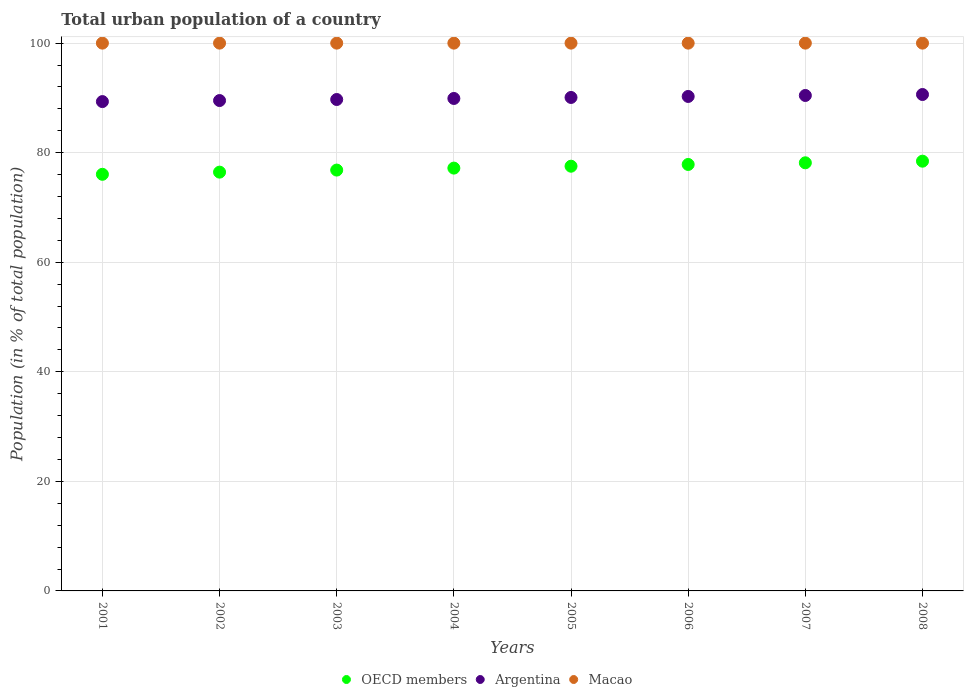What is the urban population in Argentina in 2003?
Your response must be concise. 89.71. Across all years, what is the maximum urban population in Argentina?
Your answer should be compact. 90.62. Across all years, what is the minimum urban population in Argentina?
Provide a short and direct response. 89.33. What is the total urban population in Macao in the graph?
Keep it short and to the point. 800. What is the difference between the urban population in Argentina in 2005 and that in 2007?
Give a very brief answer. -0.36. What is the difference between the urban population in OECD members in 2006 and the urban population in Argentina in 2004?
Provide a succinct answer. -12.05. What is the average urban population in OECD members per year?
Your answer should be very brief. 77.31. In the year 2005, what is the difference between the urban population in Argentina and urban population in Macao?
Your answer should be very brief. -9.92. What is the ratio of the urban population in OECD members in 2003 to that in 2008?
Keep it short and to the point. 0.98. What is the difference between the highest and the second highest urban population in Argentina?
Offer a terse response. 0.18. What is the difference between the highest and the lowest urban population in Macao?
Offer a terse response. 0. Is it the case that in every year, the sum of the urban population in Macao and urban population in OECD members  is greater than the urban population in Argentina?
Keep it short and to the point. Yes. Does the urban population in Macao monotonically increase over the years?
Ensure brevity in your answer.  No. What is the difference between two consecutive major ticks on the Y-axis?
Give a very brief answer. 20. Does the graph contain any zero values?
Your answer should be compact. No. Where does the legend appear in the graph?
Your answer should be compact. Bottom center. How many legend labels are there?
Keep it short and to the point. 3. How are the legend labels stacked?
Offer a very short reply. Horizontal. What is the title of the graph?
Ensure brevity in your answer.  Total urban population of a country. What is the label or title of the Y-axis?
Your answer should be compact. Population (in % of total population). What is the Population (in % of total population) of OECD members in 2001?
Provide a short and direct response. 76.05. What is the Population (in % of total population) in Argentina in 2001?
Your response must be concise. 89.33. What is the Population (in % of total population) of OECD members in 2002?
Offer a terse response. 76.45. What is the Population (in % of total population) of Argentina in 2002?
Offer a very short reply. 89.52. What is the Population (in % of total population) of Macao in 2002?
Offer a very short reply. 100. What is the Population (in % of total population) of OECD members in 2003?
Provide a short and direct response. 76.83. What is the Population (in % of total population) of Argentina in 2003?
Offer a very short reply. 89.71. What is the Population (in % of total population) of OECD members in 2004?
Offer a very short reply. 77.19. What is the Population (in % of total population) in Argentina in 2004?
Your response must be concise. 89.9. What is the Population (in % of total population) in OECD members in 2005?
Your answer should be compact. 77.53. What is the Population (in % of total population) of Argentina in 2005?
Your answer should be compact. 90.08. What is the Population (in % of total population) in Macao in 2005?
Your answer should be compact. 100. What is the Population (in % of total population) of OECD members in 2006?
Your answer should be very brief. 77.85. What is the Population (in % of total population) of Argentina in 2006?
Provide a short and direct response. 90.27. What is the Population (in % of total population) in Macao in 2006?
Offer a terse response. 100. What is the Population (in % of total population) in OECD members in 2007?
Keep it short and to the point. 78.15. What is the Population (in % of total population) in Argentina in 2007?
Your answer should be compact. 90.44. What is the Population (in % of total population) of Macao in 2007?
Your answer should be very brief. 100. What is the Population (in % of total population) of OECD members in 2008?
Your response must be concise. 78.45. What is the Population (in % of total population) in Argentina in 2008?
Give a very brief answer. 90.62. Across all years, what is the maximum Population (in % of total population) in OECD members?
Keep it short and to the point. 78.45. Across all years, what is the maximum Population (in % of total population) in Argentina?
Your answer should be very brief. 90.62. Across all years, what is the maximum Population (in % of total population) in Macao?
Offer a very short reply. 100. Across all years, what is the minimum Population (in % of total population) of OECD members?
Give a very brief answer. 76.05. Across all years, what is the minimum Population (in % of total population) of Argentina?
Your answer should be very brief. 89.33. Across all years, what is the minimum Population (in % of total population) in Macao?
Keep it short and to the point. 100. What is the total Population (in % of total population) in OECD members in the graph?
Provide a short and direct response. 618.51. What is the total Population (in % of total population) in Argentina in the graph?
Your answer should be compact. 719.87. What is the total Population (in % of total population) in Macao in the graph?
Provide a succinct answer. 800. What is the difference between the Population (in % of total population) of OECD members in 2001 and that in 2002?
Offer a very short reply. -0.4. What is the difference between the Population (in % of total population) in Argentina in 2001 and that in 2002?
Keep it short and to the point. -0.19. What is the difference between the Population (in % of total population) in OECD members in 2001 and that in 2003?
Keep it short and to the point. -0.77. What is the difference between the Population (in % of total population) in Argentina in 2001 and that in 2003?
Provide a succinct answer. -0.38. What is the difference between the Population (in % of total population) in OECD members in 2001 and that in 2004?
Offer a very short reply. -1.13. What is the difference between the Population (in % of total population) of Argentina in 2001 and that in 2004?
Offer a terse response. -0.57. What is the difference between the Population (in % of total population) of Macao in 2001 and that in 2004?
Offer a very short reply. 0. What is the difference between the Population (in % of total population) of OECD members in 2001 and that in 2005?
Provide a short and direct response. -1.48. What is the difference between the Population (in % of total population) of Argentina in 2001 and that in 2005?
Keep it short and to the point. -0.76. What is the difference between the Population (in % of total population) of Macao in 2001 and that in 2005?
Provide a short and direct response. 0. What is the difference between the Population (in % of total population) in OECD members in 2001 and that in 2006?
Keep it short and to the point. -1.8. What is the difference between the Population (in % of total population) of Argentina in 2001 and that in 2006?
Ensure brevity in your answer.  -0.94. What is the difference between the Population (in % of total population) in OECD members in 2001 and that in 2007?
Provide a short and direct response. -2.1. What is the difference between the Population (in % of total population) of Argentina in 2001 and that in 2007?
Offer a very short reply. -1.12. What is the difference between the Population (in % of total population) of OECD members in 2001 and that in 2008?
Your answer should be very brief. -2.4. What is the difference between the Population (in % of total population) of Argentina in 2001 and that in 2008?
Offer a terse response. -1.29. What is the difference between the Population (in % of total population) in OECD members in 2002 and that in 2003?
Provide a succinct answer. -0.38. What is the difference between the Population (in % of total population) of Argentina in 2002 and that in 2003?
Give a very brief answer. -0.19. What is the difference between the Population (in % of total population) in Macao in 2002 and that in 2003?
Your answer should be compact. 0. What is the difference between the Population (in % of total population) of OECD members in 2002 and that in 2004?
Your answer should be very brief. -0.74. What is the difference between the Population (in % of total population) of Argentina in 2002 and that in 2004?
Ensure brevity in your answer.  -0.38. What is the difference between the Population (in % of total population) of Macao in 2002 and that in 2004?
Your answer should be very brief. 0. What is the difference between the Population (in % of total population) of OECD members in 2002 and that in 2005?
Ensure brevity in your answer.  -1.08. What is the difference between the Population (in % of total population) in Argentina in 2002 and that in 2005?
Provide a short and direct response. -0.56. What is the difference between the Population (in % of total population) in OECD members in 2002 and that in 2006?
Offer a terse response. -1.4. What is the difference between the Population (in % of total population) in Argentina in 2002 and that in 2006?
Give a very brief answer. -0.75. What is the difference between the Population (in % of total population) of OECD members in 2002 and that in 2007?
Make the answer very short. -1.7. What is the difference between the Population (in % of total population) of Argentina in 2002 and that in 2007?
Your answer should be very brief. -0.93. What is the difference between the Population (in % of total population) in Macao in 2002 and that in 2007?
Your answer should be very brief. 0. What is the difference between the Population (in % of total population) in OECD members in 2002 and that in 2008?
Offer a terse response. -2. What is the difference between the Population (in % of total population) of Argentina in 2002 and that in 2008?
Offer a terse response. -1.1. What is the difference between the Population (in % of total population) of Macao in 2002 and that in 2008?
Offer a terse response. 0. What is the difference between the Population (in % of total population) in OECD members in 2003 and that in 2004?
Your answer should be compact. -0.36. What is the difference between the Population (in % of total population) of Argentina in 2003 and that in 2004?
Provide a succinct answer. -0.19. What is the difference between the Population (in % of total population) of Macao in 2003 and that in 2004?
Provide a short and direct response. 0. What is the difference between the Population (in % of total population) of OECD members in 2003 and that in 2005?
Provide a short and direct response. -0.71. What is the difference between the Population (in % of total population) of Argentina in 2003 and that in 2005?
Provide a short and direct response. -0.37. What is the difference between the Population (in % of total population) of OECD members in 2003 and that in 2006?
Keep it short and to the point. -1.02. What is the difference between the Population (in % of total population) of Argentina in 2003 and that in 2006?
Keep it short and to the point. -0.56. What is the difference between the Population (in % of total population) of OECD members in 2003 and that in 2007?
Keep it short and to the point. -1.33. What is the difference between the Population (in % of total population) in Argentina in 2003 and that in 2007?
Make the answer very short. -0.73. What is the difference between the Population (in % of total population) in OECD members in 2003 and that in 2008?
Your response must be concise. -1.62. What is the difference between the Population (in % of total population) of Argentina in 2003 and that in 2008?
Keep it short and to the point. -0.91. What is the difference between the Population (in % of total population) in OECD members in 2004 and that in 2005?
Make the answer very short. -0.35. What is the difference between the Population (in % of total population) in Argentina in 2004 and that in 2005?
Give a very brief answer. -0.18. What is the difference between the Population (in % of total population) in Macao in 2004 and that in 2005?
Give a very brief answer. 0. What is the difference between the Population (in % of total population) in OECD members in 2004 and that in 2006?
Provide a short and direct response. -0.66. What is the difference between the Population (in % of total population) of Argentina in 2004 and that in 2006?
Offer a terse response. -0.37. What is the difference between the Population (in % of total population) of OECD members in 2004 and that in 2007?
Your answer should be compact. -0.97. What is the difference between the Population (in % of total population) in Argentina in 2004 and that in 2007?
Provide a succinct answer. -0.55. What is the difference between the Population (in % of total population) in Macao in 2004 and that in 2007?
Provide a short and direct response. 0. What is the difference between the Population (in % of total population) of OECD members in 2004 and that in 2008?
Ensure brevity in your answer.  -1.26. What is the difference between the Population (in % of total population) of Argentina in 2004 and that in 2008?
Make the answer very short. -0.72. What is the difference between the Population (in % of total population) in OECD members in 2005 and that in 2006?
Provide a short and direct response. -0.32. What is the difference between the Population (in % of total population) of Argentina in 2005 and that in 2006?
Provide a short and direct response. -0.18. What is the difference between the Population (in % of total population) in OECD members in 2005 and that in 2007?
Give a very brief answer. -0.62. What is the difference between the Population (in % of total population) of Argentina in 2005 and that in 2007?
Give a very brief answer. -0.36. What is the difference between the Population (in % of total population) in OECD members in 2005 and that in 2008?
Give a very brief answer. -0.92. What is the difference between the Population (in % of total population) of Argentina in 2005 and that in 2008?
Offer a very short reply. -0.54. What is the difference between the Population (in % of total population) of Macao in 2005 and that in 2008?
Give a very brief answer. 0. What is the difference between the Population (in % of total population) in OECD members in 2006 and that in 2007?
Make the answer very short. -0.3. What is the difference between the Population (in % of total population) of Argentina in 2006 and that in 2007?
Provide a succinct answer. -0.18. What is the difference between the Population (in % of total population) in Macao in 2006 and that in 2007?
Your answer should be very brief. 0. What is the difference between the Population (in % of total population) of OECD members in 2006 and that in 2008?
Provide a short and direct response. -0.6. What is the difference between the Population (in % of total population) of Argentina in 2006 and that in 2008?
Ensure brevity in your answer.  -0.36. What is the difference between the Population (in % of total population) in Macao in 2006 and that in 2008?
Keep it short and to the point. 0. What is the difference between the Population (in % of total population) in OECD members in 2007 and that in 2008?
Keep it short and to the point. -0.3. What is the difference between the Population (in % of total population) of Argentina in 2007 and that in 2008?
Keep it short and to the point. -0.18. What is the difference between the Population (in % of total population) of OECD members in 2001 and the Population (in % of total population) of Argentina in 2002?
Offer a very short reply. -13.46. What is the difference between the Population (in % of total population) of OECD members in 2001 and the Population (in % of total population) of Macao in 2002?
Your response must be concise. -23.95. What is the difference between the Population (in % of total population) of Argentina in 2001 and the Population (in % of total population) of Macao in 2002?
Keep it short and to the point. -10.67. What is the difference between the Population (in % of total population) of OECD members in 2001 and the Population (in % of total population) of Argentina in 2003?
Offer a very short reply. -13.66. What is the difference between the Population (in % of total population) in OECD members in 2001 and the Population (in % of total population) in Macao in 2003?
Your response must be concise. -23.95. What is the difference between the Population (in % of total population) of Argentina in 2001 and the Population (in % of total population) of Macao in 2003?
Your answer should be compact. -10.67. What is the difference between the Population (in % of total population) in OECD members in 2001 and the Population (in % of total population) in Argentina in 2004?
Give a very brief answer. -13.84. What is the difference between the Population (in % of total population) in OECD members in 2001 and the Population (in % of total population) in Macao in 2004?
Ensure brevity in your answer.  -23.95. What is the difference between the Population (in % of total population) in Argentina in 2001 and the Population (in % of total population) in Macao in 2004?
Keep it short and to the point. -10.67. What is the difference between the Population (in % of total population) of OECD members in 2001 and the Population (in % of total population) of Argentina in 2005?
Offer a very short reply. -14.03. What is the difference between the Population (in % of total population) in OECD members in 2001 and the Population (in % of total population) in Macao in 2005?
Make the answer very short. -23.95. What is the difference between the Population (in % of total population) of Argentina in 2001 and the Population (in % of total population) of Macao in 2005?
Make the answer very short. -10.67. What is the difference between the Population (in % of total population) of OECD members in 2001 and the Population (in % of total population) of Argentina in 2006?
Provide a succinct answer. -14.21. What is the difference between the Population (in % of total population) of OECD members in 2001 and the Population (in % of total population) of Macao in 2006?
Make the answer very short. -23.95. What is the difference between the Population (in % of total population) of Argentina in 2001 and the Population (in % of total population) of Macao in 2006?
Offer a terse response. -10.67. What is the difference between the Population (in % of total population) of OECD members in 2001 and the Population (in % of total population) of Argentina in 2007?
Offer a terse response. -14.39. What is the difference between the Population (in % of total population) in OECD members in 2001 and the Population (in % of total population) in Macao in 2007?
Offer a terse response. -23.95. What is the difference between the Population (in % of total population) in Argentina in 2001 and the Population (in % of total population) in Macao in 2007?
Offer a terse response. -10.67. What is the difference between the Population (in % of total population) in OECD members in 2001 and the Population (in % of total population) in Argentina in 2008?
Keep it short and to the point. -14.57. What is the difference between the Population (in % of total population) of OECD members in 2001 and the Population (in % of total population) of Macao in 2008?
Your answer should be very brief. -23.95. What is the difference between the Population (in % of total population) of Argentina in 2001 and the Population (in % of total population) of Macao in 2008?
Ensure brevity in your answer.  -10.67. What is the difference between the Population (in % of total population) of OECD members in 2002 and the Population (in % of total population) of Argentina in 2003?
Make the answer very short. -13.26. What is the difference between the Population (in % of total population) in OECD members in 2002 and the Population (in % of total population) in Macao in 2003?
Provide a succinct answer. -23.55. What is the difference between the Population (in % of total population) in Argentina in 2002 and the Population (in % of total population) in Macao in 2003?
Your answer should be compact. -10.48. What is the difference between the Population (in % of total population) of OECD members in 2002 and the Population (in % of total population) of Argentina in 2004?
Offer a terse response. -13.45. What is the difference between the Population (in % of total population) in OECD members in 2002 and the Population (in % of total population) in Macao in 2004?
Give a very brief answer. -23.55. What is the difference between the Population (in % of total population) in Argentina in 2002 and the Population (in % of total population) in Macao in 2004?
Make the answer very short. -10.48. What is the difference between the Population (in % of total population) in OECD members in 2002 and the Population (in % of total population) in Argentina in 2005?
Your response must be concise. -13.63. What is the difference between the Population (in % of total population) of OECD members in 2002 and the Population (in % of total population) of Macao in 2005?
Offer a terse response. -23.55. What is the difference between the Population (in % of total population) of Argentina in 2002 and the Population (in % of total population) of Macao in 2005?
Offer a very short reply. -10.48. What is the difference between the Population (in % of total population) in OECD members in 2002 and the Population (in % of total population) in Argentina in 2006?
Provide a succinct answer. -13.82. What is the difference between the Population (in % of total population) in OECD members in 2002 and the Population (in % of total population) in Macao in 2006?
Provide a short and direct response. -23.55. What is the difference between the Population (in % of total population) in Argentina in 2002 and the Population (in % of total population) in Macao in 2006?
Keep it short and to the point. -10.48. What is the difference between the Population (in % of total population) in OECD members in 2002 and the Population (in % of total population) in Argentina in 2007?
Your response must be concise. -14. What is the difference between the Population (in % of total population) in OECD members in 2002 and the Population (in % of total population) in Macao in 2007?
Ensure brevity in your answer.  -23.55. What is the difference between the Population (in % of total population) in Argentina in 2002 and the Population (in % of total population) in Macao in 2007?
Provide a succinct answer. -10.48. What is the difference between the Population (in % of total population) in OECD members in 2002 and the Population (in % of total population) in Argentina in 2008?
Offer a very short reply. -14.17. What is the difference between the Population (in % of total population) in OECD members in 2002 and the Population (in % of total population) in Macao in 2008?
Offer a terse response. -23.55. What is the difference between the Population (in % of total population) of Argentina in 2002 and the Population (in % of total population) of Macao in 2008?
Your answer should be very brief. -10.48. What is the difference between the Population (in % of total population) of OECD members in 2003 and the Population (in % of total population) of Argentina in 2004?
Ensure brevity in your answer.  -13.07. What is the difference between the Population (in % of total population) of OECD members in 2003 and the Population (in % of total population) of Macao in 2004?
Give a very brief answer. -23.17. What is the difference between the Population (in % of total population) in Argentina in 2003 and the Population (in % of total population) in Macao in 2004?
Your answer should be compact. -10.29. What is the difference between the Population (in % of total population) of OECD members in 2003 and the Population (in % of total population) of Argentina in 2005?
Provide a succinct answer. -13.26. What is the difference between the Population (in % of total population) in OECD members in 2003 and the Population (in % of total population) in Macao in 2005?
Provide a succinct answer. -23.17. What is the difference between the Population (in % of total population) in Argentina in 2003 and the Population (in % of total population) in Macao in 2005?
Make the answer very short. -10.29. What is the difference between the Population (in % of total population) of OECD members in 2003 and the Population (in % of total population) of Argentina in 2006?
Offer a terse response. -13.44. What is the difference between the Population (in % of total population) of OECD members in 2003 and the Population (in % of total population) of Macao in 2006?
Offer a terse response. -23.17. What is the difference between the Population (in % of total population) in Argentina in 2003 and the Population (in % of total population) in Macao in 2006?
Make the answer very short. -10.29. What is the difference between the Population (in % of total population) in OECD members in 2003 and the Population (in % of total population) in Argentina in 2007?
Your response must be concise. -13.62. What is the difference between the Population (in % of total population) of OECD members in 2003 and the Population (in % of total population) of Macao in 2007?
Give a very brief answer. -23.17. What is the difference between the Population (in % of total population) of Argentina in 2003 and the Population (in % of total population) of Macao in 2007?
Your response must be concise. -10.29. What is the difference between the Population (in % of total population) of OECD members in 2003 and the Population (in % of total population) of Argentina in 2008?
Make the answer very short. -13.8. What is the difference between the Population (in % of total population) in OECD members in 2003 and the Population (in % of total population) in Macao in 2008?
Your response must be concise. -23.17. What is the difference between the Population (in % of total population) in Argentina in 2003 and the Population (in % of total population) in Macao in 2008?
Keep it short and to the point. -10.29. What is the difference between the Population (in % of total population) of OECD members in 2004 and the Population (in % of total population) of Argentina in 2005?
Ensure brevity in your answer.  -12.9. What is the difference between the Population (in % of total population) in OECD members in 2004 and the Population (in % of total population) in Macao in 2005?
Ensure brevity in your answer.  -22.81. What is the difference between the Population (in % of total population) of Argentina in 2004 and the Population (in % of total population) of Macao in 2005?
Your answer should be very brief. -10.1. What is the difference between the Population (in % of total population) in OECD members in 2004 and the Population (in % of total population) in Argentina in 2006?
Provide a succinct answer. -13.08. What is the difference between the Population (in % of total population) of OECD members in 2004 and the Population (in % of total population) of Macao in 2006?
Give a very brief answer. -22.81. What is the difference between the Population (in % of total population) in Argentina in 2004 and the Population (in % of total population) in Macao in 2006?
Provide a succinct answer. -10.1. What is the difference between the Population (in % of total population) of OECD members in 2004 and the Population (in % of total population) of Argentina in 2007?
Your answer should be compact. -13.26. What is the difference between the Population (in % of total population) of OECD members in 2004 and the Population (in % of total population) of Macao in 2007?
Your response must be concise. -22.81. What is the difference between the Population (in % of total population) of Argentina in 2004 and the Population (in % of total population) of Macao in 2007?
Give a very brief answer. -10.1. What is the difference between the Population (in % of total population) of OECD members in 2004 and the Population (in % of total population) of Argentina in 2008?
Offer a very short reply. -13.44. What is the difference between the Population (in % of total population) in OECD members in 2004 and the Population (in % of total population) in Macao in 2008?
Make the answer very short. -22.81. What is the difference between the Population (in % of total population) in Argentina in 2004 and the Population (in % of total population) in Macao in 2008?
Your answer should be compact. -10.1. What is the difference between the Population (in % of total population) in OECD members in 2005 and the Population (in % of total population) in Argentina in 2006?
Make the answer very short. -12.73. What is the difference between the Population (in % of total population) of OECD members in 2005 and the Population (in % of total population) of Macao in 2006?
Ensure brevity in your answer.  -22.47. What is the difference between the Population (in % of total population) of Argentina in 2005 and the Population (in % of total population) of Macao in 2006?
Your answer should be very brief. -9.92. What is the difference between the Population (in % of total population) in OECD members in 2005 and the Population (in % of total population) in Argentina in 2007?
Ensure brevity in your answer.  -12.91. What is the difference between the Population (in % of total population) in OECD members in 2005 and the Population (in % of total population) in Macao in 2007?
Make the answer very short. -22.47. What is the difference between the Population (in % of total population) in Argentina in 2005 and the Population (in % of total population) in Macao in 2007?
Offer a very short reply. -9.92. What is the difference between the Population (in % of total population) in OECD members in 2005 and the Population (in % of total population) in Argentina in 2008?
Provide a succinct answer. -13.09. What is the difference between the Population (in % of total population) in OECD members in 2005 and the Population (in % of total population) in Macao in 2008?
Give a very brief answer. -22.47. What is the difference between the Population (in % of total population) in Argentina in 2005 and the Population (in % of total population) in Macao in 2008?
Offer a very short reply. -9.92. What is the difference between the Population (in % of total population) in OECD members in 2006 and the Population (in % of total population) in Argentina in 2007?
Provide a succinct answer. -12.59. What is the difference between the Population (in % of total population) in OECD members in 2006 and the Population (in % of total population) in Macao in 2007?
Provide a short and direct response. -22.15. What is the difference between the Population (in % of total population) of Argentina in 2006 and the Population (in % of total population) of Macao in 2007?
Provide a short and direct response. -9.73. What is the difference between the Population (in % of total population) of OECD members in 2006 and the Population (in % of total population) of Argentina in 2008?
Your answer should be compact. -12.77. What is the difference between the Population (in % of total population) of OECD members in 2006 and the Population (in % of total population) of Macao in 2008?
Provide a short and direct response. -22.15. What is the difference between the Population (in % of total population) in Argentina in 2006 and the Population (in % of total population) in Macao in 2008?
Give a very brief answer. -9.73. What is the difference between the Population (in % of total population) in OECD members in 2007 and the Population (in % of total population) in Argentina in 2008?
Give a very brief answer. -12.47. What is the difference between the Population (in % of total population) in OECD members in 2007 and the Population (in % of total population) in Macao in 2008?
Offer a very short reply. -21.85. What is the difference between the Population (in % of total population) in Argentina in 2007 and the Population (in % of total population) in Macao in 2008?
Give a very brief answer. -9.55. What is the average Population (in % of total population) in OECD members per year?
Make the answer very short. 77.31. What is the average Population (in % of total population) of Argentina per year?
Offer a very short reply. 89.98. What is the average Population (in % of total population) of Macao per year?
Your answer should be compact. 100. In the year 2001, what is the difference between the Population (in % of total population) of OECD members and Population (in % of total population) of Argentina?
Ensure brevity in your answer.  -13.27. In the year 2001, what is the difference between the Population (in % of total population) in OECD members and Population (in % of total population) in Macao?
Offer a very short reply. -23.95. In the year 2001, what is the difference between the Population (in % of total population) in Argentina and Population (in % of total population) in Macao?
Your response must be concise. -10.67. In the year 2002, what is the difference between the Population (in % of total population) in OECD members and Population (in % of total population) in Argentina?
Offer a very short reply. -13.07. In the year 2002, what is the difference between the Population (in % of total population) in OECD members and Population (in % of total population) in Macao?
Keep it short and to the point. -23.55. In the year 2002, what is the difference between the Population (in % of total population) in Argentina and Population (in % of total population) in Macao?
Ensure brevity in your answer.  -10.48. In the year 2003, what is the difference between the Population (in % of total population) of OECD members and Population (in % of total population) of Argentina?
Provide a short and direct response. -12.88. In the year 2003, what is the difference between the Population (in % of total population) in OECD members and Population (in % of total population) in Macao?
Your response must be concise. -23.17. In the year 2003, what is the difference between the Population (in % of total population) in Argentina and Population (in % of total population) in Macao?
Your response must be concise. -10.29. In the year 2004, what is the difference between the Population (in % of total population) of OECD members and Population (in % of total population) of Argentina?
Provide a succinct answer. -12.71. In the year 2004, what is the difference between the Population (in % of total population) of OECD members and Population (in % of total population) of Macao?
Offer a terse response. -22.81. In the year 2004, what is the difference between the Population (in % of total population) in Argentina and Population (in % of total population) in Macao?
Offer a terse response. -10.1. In the year 2005, what is the difference between the Population (in % of total population) of OECD members and Population (in % of total population) of Argentina?
Your answer should be very brief. -12.55. In the year 2005, what is the difference between the Population (in % of total population) of OECD members and Population (in % of total population) of Macao?
Ensure brevity in your answer.  -22.47. In the year 2005, what is the difference between the Population (in % of total population) in Argentina and Population (in % of total population) in Macao?
Give a very brief answer. -9.92. In the year 2006, what is the difference between the Population (in % of total population) of OECD members and Population (in % of total population) of Argentina?
Your answer should be compact. -12.42. In the year 2006, what is the difference between the Population (in % of total population) of OECD members and Population (in % of total population) of Macao?
Keep it short and to the point. -22.15. In the year 2006, what is the difference between the Population (in % of total population) of Argentina and Population (in % of total population) of Macao?
Provide a short and direct response. -9.73. In the year 2007, what is the difference between the Population (in % of total population) in OECD members and Population (in % of total population) in Argentina?
Provide a succinct answer. -12.29. In the year 2007, what is the difference between the Population (in % of total population) in OECD members and Population (in % of total population) in Macao?
Keep it short and to the point. -21.85. In the year 2007, what is the difference between the Population (in % of total population) in Argentina and Population (in % of total population) in Macao?
Make the answer very short. -9.55. In the year 2008, what is the difference between the Population (in % of total population) of OECD members and Population (in % of total population) of Argentina?
Your answer should be very brief. -12.17. In the year 2008, what is the difference between the Population (in % of total population) in OECD members and Population (in % of total population) in Macao?
Your response must be concise. -21.55. In the year 2008, what is the difference between the Population (in % of total population) in Argentina and Population (in % of total population) in Macao?
Give a very brief answer. -9.38. What is the ratio of the Population (in % of total population) in Macao in 2001 to that in 2003?
Your answer should be very brief. 1. What is the ratio of the Population (in % of total population) in Argentina in 2001 to that in 2004?
Your response must be concise. 0.99. What is the ratio of the Population (in % of total population) in Macao in 2001 to that in 2004?
Your answer should be compact. 1. What is the ratio of the Population (in % of total population) in OECD members in 2001 to that in 2005?
Offer a very short reply. 0.98. What is the ratio of the Population (in % of total population) in Argentina in 2001 to that in 2005?
Ensure brevity in your answer.  0.99. What is the ratio of the Population (in % of total population) in Macao in 2001 to that in 2005?
Make the answer very short. 1. What is the ratio of the Population (in % of total population) of OECD members in 2001 to that in 2006?
Offer a very short reply. 0.98. What is the ratio of the Population (in % of total population) of Argentina in 2001 to that in 2006?
Provide a succinct answer. 0.99. What is the ratio of the Population (in % of total population) in Macao in 2001 to that in 2006?
Offer a very short reply. 1. What is the ratio of the Population (in % of total population) of OECD members in 2001 to that in 2007?
Your answer should be very brief. 0.97. What is the ratio of the Population (in % of total population) in Macao in 2001 to that in 2007?
Offer a terse response. 1. What is the ratio of the Population (in % of total population) of OECD members in 2001 to that in 2008?
Your response must be concise. 0.97. What is the ratio of the Population (in % of total population) of Argentina in 2001 to that in 2008?
Offer a very short reply. 0.99. What is the ratio of the Population (in % of total population) of Macao in 2001 to that in 2008?
Your response must be concise. 1. What is the ratio of the Population (in % of total population) in OECD members in 2002 to that in 2003?
Provide a short and direct response. 1. What is the ratio of the Population (in % of total population) of OECD members in 2002 to that in 2004?
Provide a short and direct response. 0.99. What is the ratio of the Population (in % of total population) in Macao in 2002 to that in 2004?
Offer a very short reply. 1. What is the ratio of the Population (in % of total population) in OECD members in 2002 to that in 2005?
Ensure brevity in your answer.  0.99. What is the ratio of the Population (in % of total population) of Argentina in 2002 to that in 2005?
Provide a short and direct response. 0.99. What is the ratio of the Population (in % of total population) in Macao in 2002 to that in 2005?
Offer a very short reply. 1. What is the ratio of the Population (in % of total population) of OECD members in 2002 to that in 2006?
Keep it short and to the point. 0.98. What is the ratio of the Population (in % of total population) of Argentina in 2002 to that in 2006?
Offer a terse response. 0.99. What is the ratio of the Population (in % of total population) in OECD members in 2002 to that in 2007?
Offer a terse response. 0.98. What is the ratio of the Population (in % of total population) in Argentina in 2002 to that in 2007?
Your answer should be compact. 0.99. What is the ratio of the Population (in % of total population) in OECD members in 2002 to that in 2008?
Your response must be concise. 0.97. What is the ratio of the Population (in % of total population) of Argentina in 2002 to that in 2008?
Provide a succinct answer. 0.99. What is the ratio of the Population (in % of total population) of Macao in 2002 to that in 2008?
Provide a succinct answer. 1. What is the ratio of the Population (in % of total population) in Argentina in 2003 to that in 2004?
Offer a terse response. 1. What is the ratio of the Population (in % of total population) of OECD members in 2003 to that in 2005?
Your answer should be very brief. 0.99. What is the ratio of the Population (in % of total population) of Argentina in 2003 to that in 2005?
Offer a very short reply. 1. What is the ratio of the Population (in % of total population) of Macao in 2003 to that in 2005?
Offer a very short reply. 1. What is the ratio of the Population (in % of total population) of Argentina in 2003 to that in 2006?
Offer a terse response. 0.99. What is the ratio of the Population (in % of total population) in Macao in 2003 to that in 2006?
Keep it short and to the point. 1. What is the ratio of the Population (in % of total population) of OECD members in 2003 to that in 2007?
Your response must be concise. 0.98. What is the ratio of the Population (in % of total population) in OECD members in 2003 to that in 2008?
Keep it short and to the point. 0.98. What is the ratio of the Population (in % of total population) in Macao in 2003 to that in 2008?
Your answer should be compact. 1. What is the ratio of the Population (in % of total population) of OECD members in 2004 to that in 2005?
Provide a short and direct response. 1. What is the ratio of the Population (in % of total population) of Argentina in 2004 to that in 2005?
Give a very brief answer. 1. What is the ratio of the Population (in % of total population) of Macao in 2004 to that in 2005?
Provide a succinct answer. 1. What is the ratio of the Population (in % of total population) of OECD members in 2004 to that in 2006?
Offer a very short reply. 0.99. What is the ratio of the Population (in % of total population) in Macao in 2004 to that in 2006?
Your answer should be compact. 1. What is the ratio of the Population (in % of total population) in OECD members in 2004 to that in 2007?
Your answer should be very brief. 0.99. What is the ratio of the Population (in % of total population) in Argentina in 2004 to that in 2007?
Keep it short and to the point. 0.99. What is the ratio of the Population (in % of total population) of OECD members in 2004 to that in 2008?
Your answer should be compact. 0.98. What is the ratio of the Population (in % of total population) of Argentina in 2004 to that in 2008?
Make the answer very short. 0.99. What is the ratio of the Population (in % of total population) of Macao in 2004 to that in 2008?
Keep it short and to the point. 1. What is the ratio of the Population (in % of total population) of OECD members in 2005 to that in 2006?
Your answer should be very brief. 1. What is the ratio of the Population (in % of total population) in OECD members in 2005 to that in 2007?
Make the answer very short. 0.99. What is the ratio of the Population (in % of total population) of Argentina in 2005 to that in 2007?
Your answer should be very brief. 1. What is the ratio of the Population (in % of total population) in Macao in 2005 to that in 2007?
Provide a short and direct response. 1. What is the ratio of the Population (in % of total population) of OECD members in 2005 to that in 2008?
Your answer should be very brief. 0.99. What is the ratio of the Population (in % of total population) of Argentina in 2005 to that in 2008?
Keep it short and to the point. 0.99. What is the ratio of the Population (in % of total population) in OECD members in 2006 to that in 2007?
Keep it short and to the point. 1. What is the ratio of the Population (in % of total population) of Argentina in 2006 to that in 2007?
Give a very brief answer. 1. What is the ratio of the Population (in % of total population) of Argentina in 2006 to that in 2008?
Offer a very short reply. 1. What is the ratio of the Population (in % of total population) of Argentina in 2007 to that in 2008?
Your answer should be very brief. 1. What is the difference between the highest and the second highest Population (in % of total population) in OECD members?
Your answer should be very brief. 0.3. What is the difference between the highest and the second highest Population (in % of total population) of Argentina?
Make the answer very short. 0.18. What is the difference between the highest and the lowest Population (in % of total population) of OECD members?
Your answer should be compact. 2.4. What is the difference between the highest and the lowest Population (in % of total population) in Argentina?
Offer a very short reply. 1.29. What is the difference between the highest and the lowest Population (in % of total population) of Macao?
Your response must be concise. 0. 